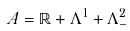Convert formula to latex. <formula><loc_0><loc_0><loc_500><loc_500>\ A = \mathbb { R } + \Lambda ^ { 1 } + \Lambda ^ { 2 } _ { - }</formula> 